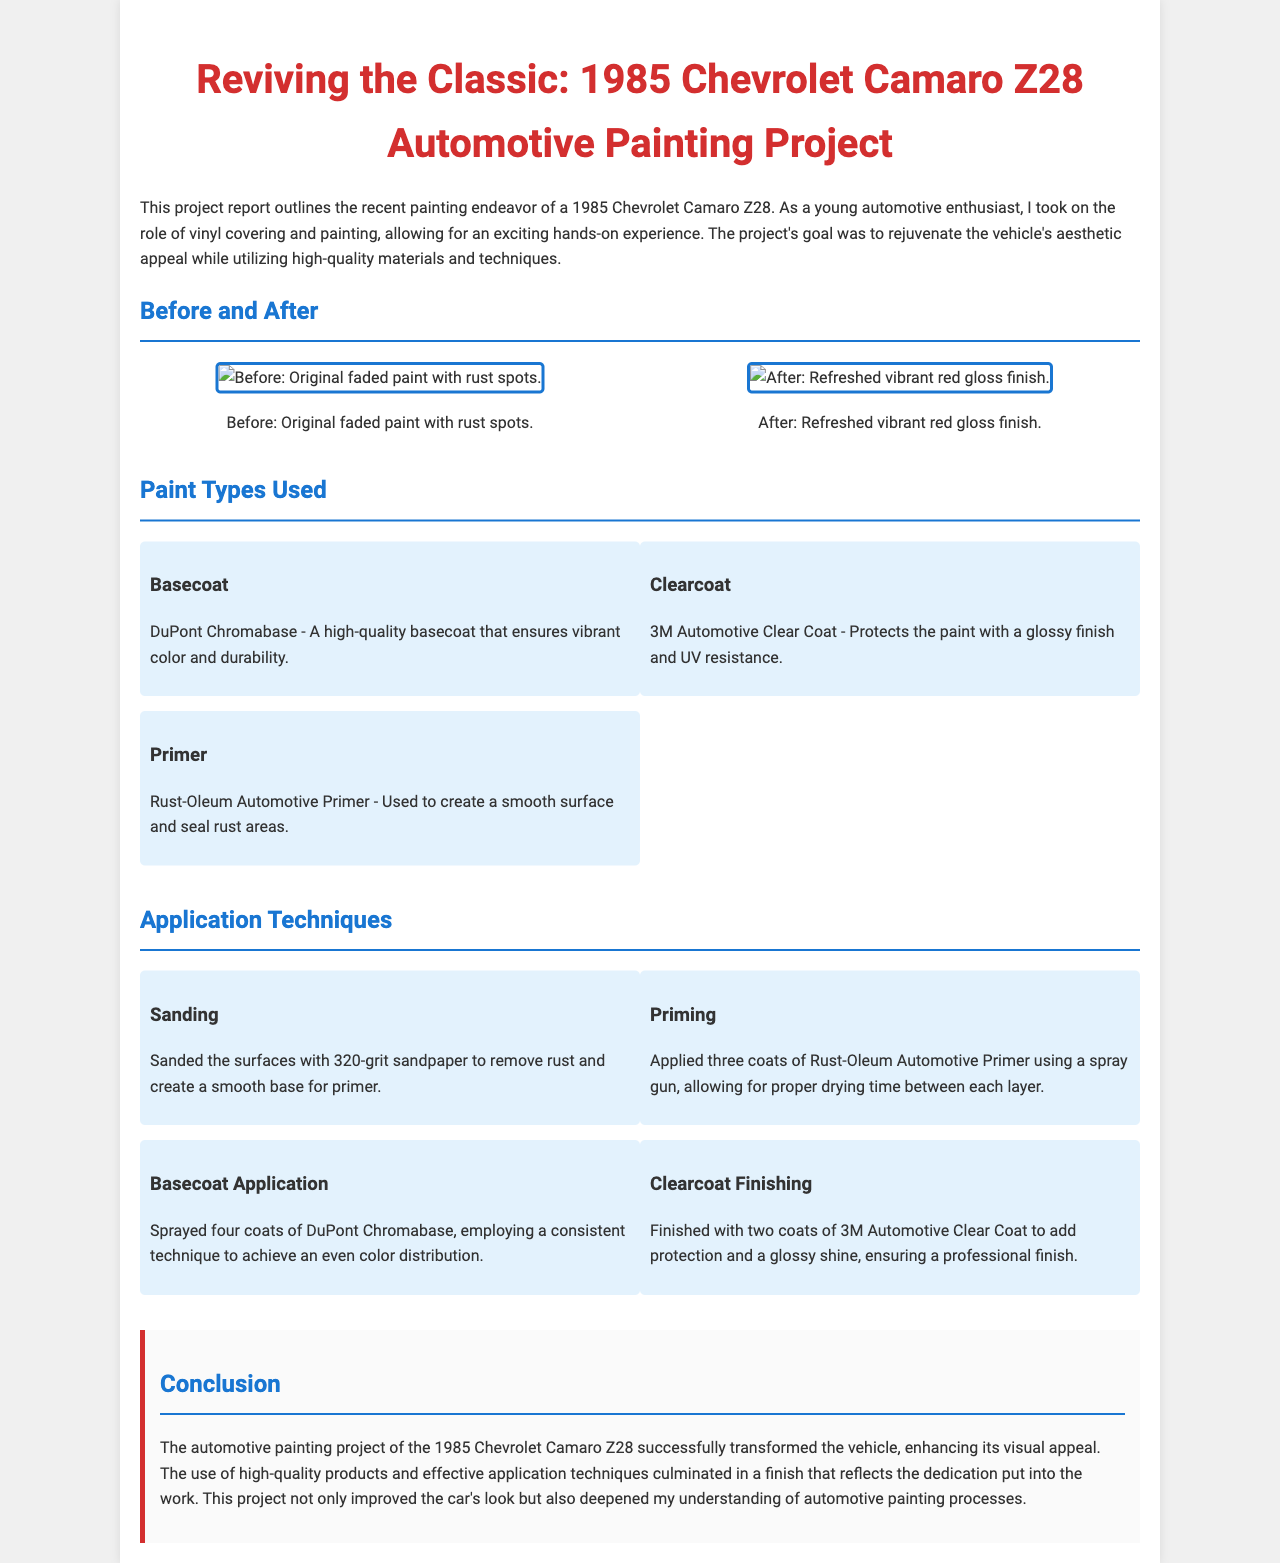what is the title of the report? The title of the report is mentioned at the beginning of the document, which is about a specific painting project.
Answer: Reviving the Classic: 1985 Chevrolet Camaro Z28 Automotive Painting Project what type of finish was applied last? The last finishing step in the painting process is described in the section on application techniques, focusing on providing a gloss and protection to the paint.
Answer: 3M Automotive Clear Coat how many coats of basecoat were applied? The report specifies the number of coats used during the basecoat application.
Answer: four what was the condition of the car before painting? The original state of the car is described in the "Before" section with specific details.
Answer: Original faded paint with rust spots which primer was used in the project? The document includes a dedicated section for paint types, identifying specific products used.
Answer: Rust-Oleum Automotive Primer what was the primary technique used for smoothing the surface before painting? The application techniques section outlines the preparatory process for painting, including a specific method used for surface preparation.
Answer: Sanding how many coats of primer were applied? The details regarding the number of primer coats are provided in the techniques section of the document.
Answer: three what color was the final paint finish? The color of the paint finish after completion is noted in the "After" image description.
Answer: vibrant red gloss finish 